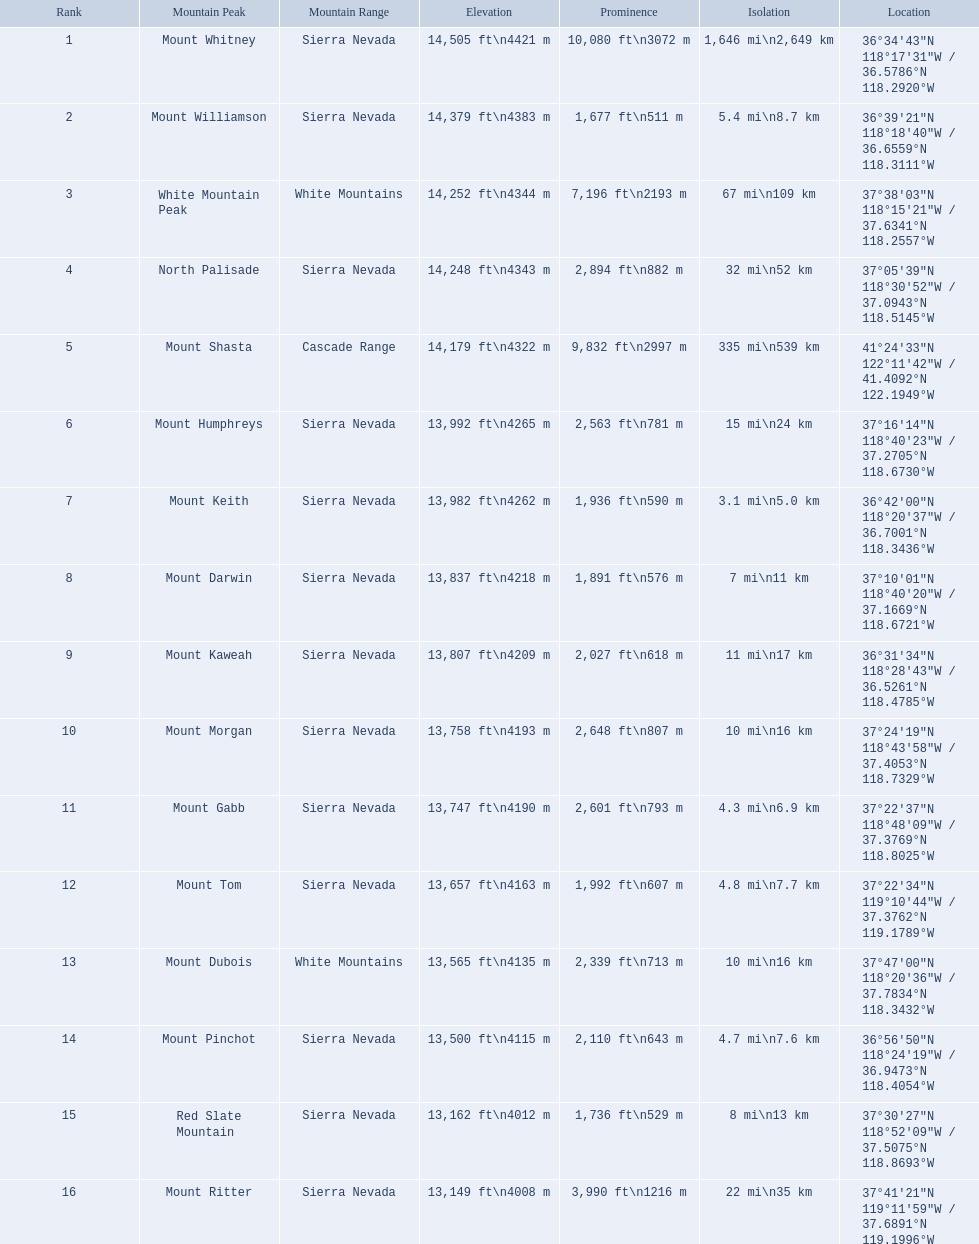What are all of the mountain peaks? Mount Whitney, Mount Williamson, White Mountain Peak, North Palisade, Mount Shasta, Mount Humphreys, Mount Keith, Mount Darwin, Mount Kaweah, Mount Morgan, Mount Gabb, Mount Tom, Mount Dubois, Mount Pinchot, Red Slate Mountain, Mount Ritter. In what ranges are they? Sierra Nevada, Sierra Nevada, White Mountains, Sierra Nevada, Cascade Range, Sierra Nevada, Sierra Nevada, Sierra Nevada, Sierra Nevada, Sierra Nevada, Sierra Nevada, Sierra Nevada, White Mountains, Sierra Nevada, Sierra Nevada, Sierra Nevada. Which peak is in the cascade range? Mount Shasta. What are the elevations of the mountain summits in california? 14,505 ft\n4421 m, 14,379 ft\n4383 m, 14,252 ft\n4344 m, 14,248 ft\n4343 m, 14,179 ft\n4322 m, 13,992 ft\n4265 m, 13,982 ft\n4262 m, 13,837 ft\n4218 m, 13,807 ft\n4209 m, 13,758 ft\n4193 m, 13,747 ft\n4190 m, 13,657 ft\n4163 m, 13,565 ft\n4135 m, 13,500 ft\n4115 m, 13,162 ft\n4012 m, 13,149 ft\n4008 m. What altitude is 13,149 ft or less? 13,149 ft\n4008 m. Which mountain peak reaches this elevation? Mount Ritter. What are the most elevated mountain peaks in california? Mount Whitney, Mount Williamson, White Mountain Peak, North Palisade, Mount Shasta, Mount Humphreys, Mount Keith, Mount Darwin, Mount Kaweah, Mount Morgan, Mount Gabb, Mount Tom, Mount Dubois, Mount Pinchot, Red Slate Mountain, Mount Ritter. From those, which ones do not belong to the sierra nevada range? White Mountain Peak, Mount Shasta, Mount Dubois. Among the mountains not in the sierra nevada range, which is the exclusive peak in the cascades? Mount Shasta. 